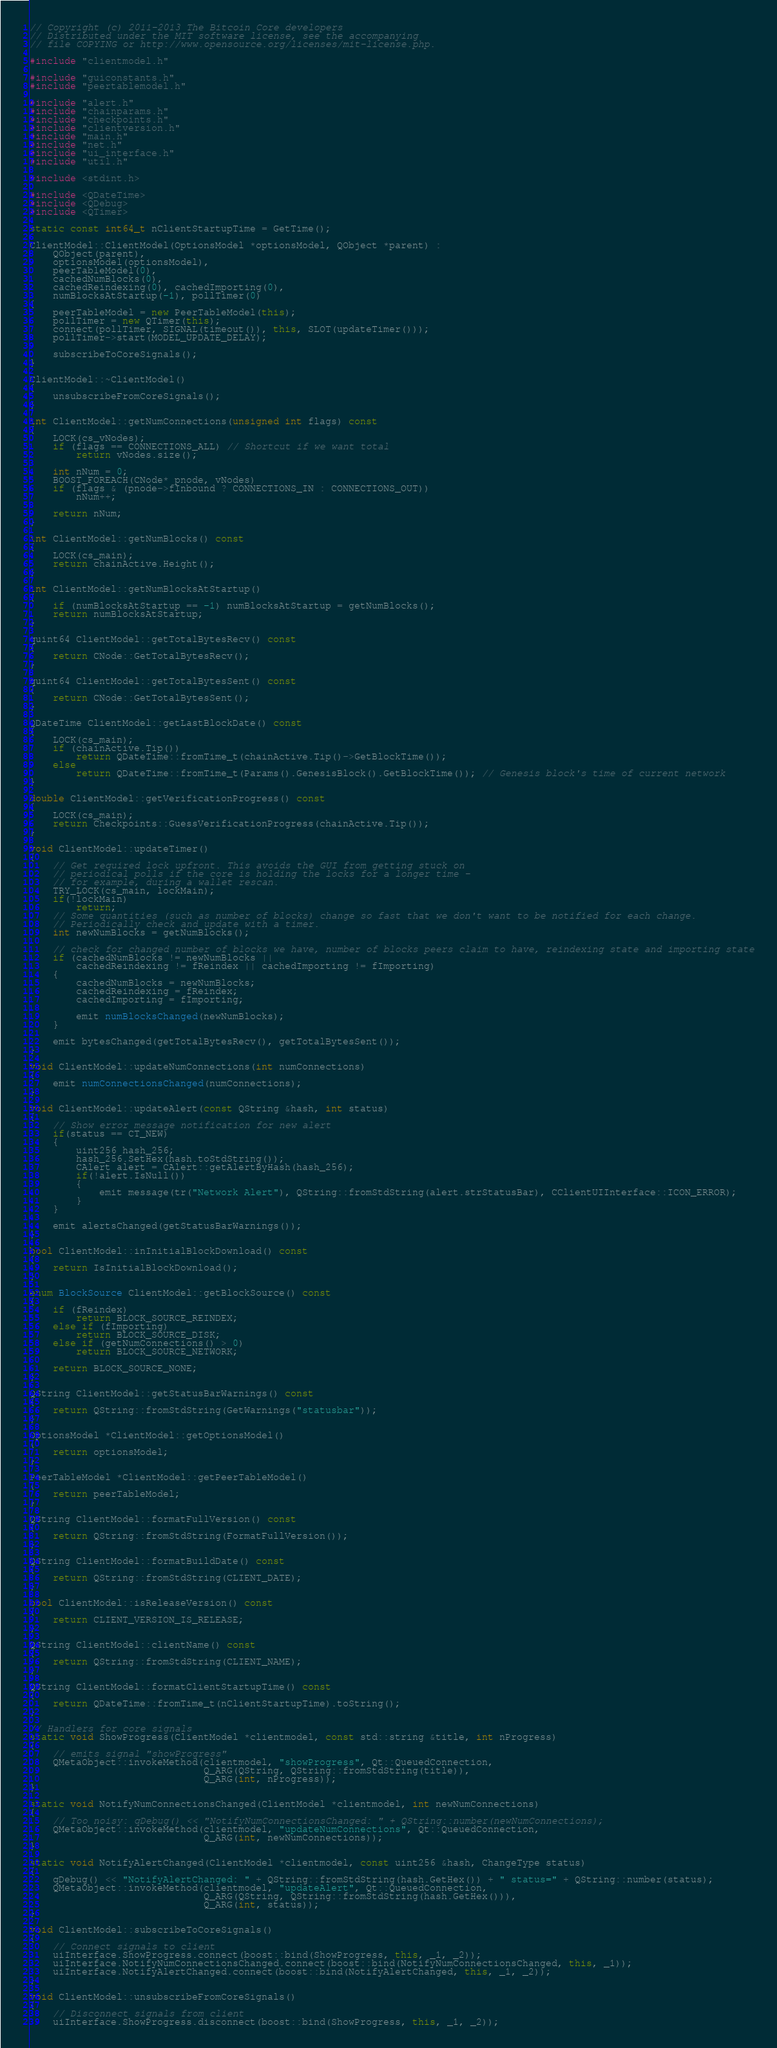Convert code to text. <code><loc_0><loc_0><loc_500><loc_500><_C++_>// Copyright (c) 2011-2013 The Bitcoin Core developers
// Distributed under the MIT software license, see the accompanying
// file COPYING or http://www.opensource.org/licenses/mit-license.php.

#include "clientmodel.h"

#include "guiconstants.h"
#include "peertablemodel.h"

#include "alert.h"
#include "chainparams.h"
#include "checkpoints.h"
#include "clientversion.h"
#include "main.h"
#include "net.h"
#include "ui_interface.h"
#include "util.h"

#include <stdint.h>

#include <QDateTime>
#include <QDebug>
#include <QTimer>

static const int64_t nClientStartupTime = GetTime();

ClientModel::ClientModel(OptionsModel *optionsModel, QObject *parent) :
    QObject(parent),
    optionsModel(optionsModel),
    peerTableModel(0),
    cachedNumBlocks(0),
    cachedReindexing(0), cachedImporting(0),
    numBlocksAtStartup(-1), pollTimer(0)
{
    peerTableModel = new PeerTableModel(this);
    pollTimer = new QTimer(this);
    connect(pollTimer, SIGNAL(timeout()), this, SLOT(updateTimer()));
    pollTimer->start(MODEL_UPDATE_DELAY);

    subscribeToCoreSignals();
}

ClientModel::~ClientModel()
{
    unsubscribeFromCoreSignals();
}

int ClientModel::getNumConnections(unsigned int flags) const
{
    LOCK(cs_vNodes);
    if (flags == CONNECTIONS_ALL) // Shortcut if we want total
        return vNodes.size();

    int nNum = 0;
    BOOST_FOREACH(CNode* pnode, vNodes)
    if (flags & (pnode->fInbound ? CONNECTIONS_IN : CONNECTIONS_OUT))
        nNum++;

    return nNum;
}

int ClientModel::getNumBlocks() const
{
    LOCK(cs_main);
    return chainActive.Height();
}

int ClientModel::getNumBlocksAtStartup()
{
    if (numBlocksAtStartup == -1) numBlocksAtStartup = getNumBlocks();
    return numBlocksAtStartup;
}

quint64 ClientModel::getTotalBytesRecv() const
{
    return CNode::GetTotalBytesRecv();
}

quint64 ClientModel::getTotalBytesSent() const
{
    return CNode::GetTotalBytesSent();
}

QDateTime ClientModel::getLastBlockDate() const
{
    LOCK(cs_main);
    if (chainActive.Tip())
        return QDateTime::fromTime_t(chainActive.Tip()->GetBlockTime());
    else
        return QDateTime::fromTime_t(Params().GenesisBlock().GetBlockTime()); // Genesis block's time of current network
}

double ClientModel::getVerificationProgress() const
{
    LOCK(cs_main);
    return Checkpoints::GuessVerificationProgress(chainActive.Tip());
}

void ClientModel::updateTimer()
{
    // Get required lock upfront. This avoids the GUI from getting stuck on
    // periodical polls if the core is holding the locks for a longer time -
    // for example, during a wallet rescan.
    TRY_LOCK(cs_main, lockMain);
    if(!lockMain)
        return;
    // Some quantities (such as number of blocks) change so fast that we don't want to be notified for each change.
    // Periodically check and update with a timer.
    int newNumBlocks = getNumBlocks();

    // check for changed number of blocks we have, number of blocks peers claim to have, reindexing state and importing state
    if (cachedNumBlocks != newNumBlocks ||
        cachedReindexing != fReindex || cachedImporting != fImporting)
    {
        cachedNumBlocks = newNumBlocks;
        cachedReindexing = fReindex;
        cachedImporting = fImporting;

        emit numBlocksChanged(newNumBlocks);
    }

    emit bytesChanged(getTotalBytesRecv(), getTotalBytesSent());
}

void ClientModel::updateNumConnections(int numConnections)
{
    emit numConnectionsChanged(numConnections);
}

void ClientModel::updateAlert(const QString &hash, int status)
{
    // Show error message notification for new alert
    if(status == CT_NEW)
    {
        uint256 hash_256;
        hash_256.SetHex(hash.toStdString());
        CAlert alert = CAlert::getAlertByHash(hash_256);
        if(!alert.IsNull())
        {
            emit message(tr("Network Alert"), QString::fromStdString(alert.strStatusBar), CClientUIInterface::ICON_ERROR);
        }
    }

    emit alertsChanged(getStatusBarWarnings());
}

bool ClientModel::inInitialBlockDownload() const
{
    return IsInitialBlockDownload();
}

enum BlockSource ClientModel::getBlockSource() const
{
    if (fReindex)
        return BLOCK_SOURCE_REINDEX;
    else if (fImporting)
        return BLOCK_SOURCE_DISK;
    else if (getNumConnections() > 0)
        return BLOCK_SOURCE_NETWORK;

    return BLOCK_SOURCE_NONE;
}

QString ClientModel::getStatusBarWarnings() const
{
    return QString::fromStdString(GetWarnings("statusbar"));
}

OptionsModel *ClientModel::getOptionsModel()
{
    return optionsModel;
}

PeerTableModel *ClientModel::getPeerTableModel()
{
    return peerTableModel;
}

QString ClientModel::formatFullVersion() const
{
    return QString::fromStdString(FormatFullVersion());
}

QString ClientModel::formatBuildDate() const
{
    return QString::fromStdString(CLIENT_DATE);
}

bool ClientModel::isReleaseVersion() const
{
    return CLIENT_VERSION_IS_RELEASE;
}

QString ClientModel::clientName() const
{
    return QString::fromStdString(CLIENT_NAME);
}

QString ClientModel::formatClientStartupTime() const
{
    return QDateTime::fromTime_t(nClientStartupTime).toString();
}

// Handlers for core signals
static void ShowProgress(ClientModel *clientmodel, const std::string &title, int nProgress)
{
    // emits signal "showProgress"
    QMetaObject::invokeMethod(clientmodel, "showProgress", Qt::QueuedConnection,
                              Q_ARG(QString, QString::fromStdString(title)),
                              Q_ARG(int, nProgress));
}

static void NotifyNumConnectionsChanged(ClientModel *clientmodel, int newNumConnections)
{
    // Too noisy: qDebug() << "NotifyNumConnectionsChanged: " + QString::number(newNumConnections);
    QMetaObject::invokeMethod(clientmodel, "updateNumConnections", Qt::QueuedConnection,
                              Q_ARG(int, newNumConnections));
}

static void NotifyAlertChanged(ClientModel *clientmodel, const uint256 &hash, ChangeType status)
{
    qDebug() << "NotifyAlertChanged: " + QString::fromStdString(hash.GetHex()) + " status=" + QString::number(status);
    QMetaObject::invokeMethod(clientmodel, "updateAlert", Qt::QueuedConnection,
                              Q_ARG(QString, QString::fromStdString(hash.GetHex())),
                              Q_ARG(int, status));
}

void ClientModel::subscribeToCoreSignals()
{
    // Connect signals to client
    uiInterface.ShowProgress.connect(boost::bind(ShowProgress, this, _1, _2));
    uiInterface.NotifyNumConnectionsChanged.connect(boost::bind(NotifyNumConnectionsChanged, this, _1));
    uiInterface.NotifyAlertChanged.connect(boost::bind(NotifyAlertChanged, this, _1, _2));
}

void ClientModel::unsubscribeFromCoreSignals()
{
    // Disconnect signals from client
    uiInterface.ShowProgress.disconnect(boost::bind(ShowProgress, this, _1, _2));</code> 